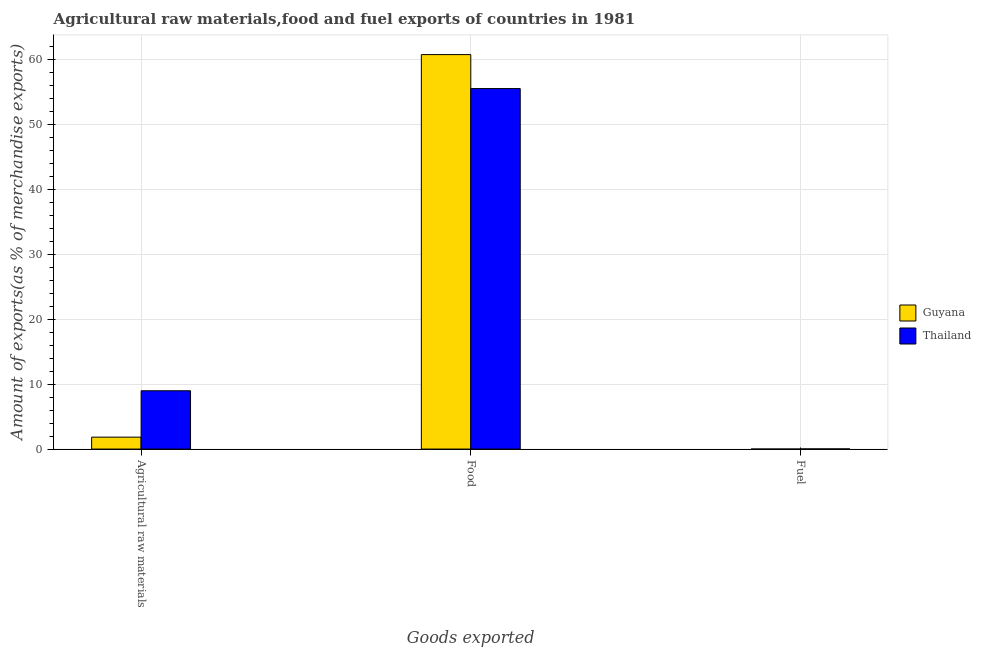How many different coloured bars are there?
Offer a terse response. 2. How many groups of bars are there?
Provide a short and direct response. 3. Are the number of bars on each tick of the X-axis equal?
Offer a very short reply. Yes. How many bars are there on the 1st tick from the right?
Your response must be concise. 2. What is the label of the 2nd group of bars from the left?
Offer a terse response. Food. What is the percentage of fuel exports in Thailand?
Offer a very short reply. 0.02. Across all countries, what is the maximum percentage of food exports?
Your response must be concise. 60.74. Across all countries, what is the minimum percentage of food exports?
Your answer should be very brief. 55.51. In which country was the percentage of fuel exports maximum?
Your answer should be very brief. Thailand. In which country was the percentage of fuel exports minimum?
Your response must be concise. Guyana. What is the total percentage of raw materials exports in the graph?
Keep it short and to the point. 10.82. What is the difference between the percentage of food exports in Thailand and that in Guyana?
Keep it short and to the point. -5.23. What is the difference between the percentage of fuel exports in Guyana and the percentage of raw materials exports in Thailand?
Keep it short and to the point. -8.98. What is the average percentage of food exports per country?
Ensure brevity in your answer.  58.13. What is the difference between the percentage of fuel exports and percentage of raw materials exports in Guyana?
Make the answer very short. -1.84. In how many countries, is the percentage of food exports greater than 26 %?
Offer a terse response. 2. What is the ratio of the percentage of fuel exports in Thailand to that in Guyana?
Offer a terse response. 395.81. Is the difference between the percentage of food exports in Guyana and Thailand greater than the difference between the percentage of raw materials exports in Guyana and Thailand?
Your answer should be compact. Yes. What is the difference between the highest and the second highest percentage of fuel exports?
Provide a short and direct response. 0.02. What is the difference between the highest and the lowest percentage of food exports?
Offer a very short reply. 5.23. In how many countries, is the percentage of food exports greater than the average percentage of food exports taken over all countries?
Make the answer very short. 1. What does the 1st bar from the left in Fuel represents?
Offer a terse response. Guyana. What does the 2nd bar from the right in Agricultural raw materials represents?
Offer a very short reply. Guyana. How many bars are there?
Your answer should be compact. 6. What is the difference between two consecutive major ticks on the Y-axis?
Provide a short and direct response. 10. Where does the legend appear in the graph?
Keep it short and to the point. Center right. How are the legend labels stacked?
Offer a very short reply. Vertical. What is the title of the graph?
Offer a terse response. Agricultural raw materials,food and fuel exports of countries in 1981. Does "New Caledonia" appear as one of the legend labels in the graph?
Provide a short and direct response. No. What is the label or title of the X-axis?
Give a very brief answer. Goods exported. What is the label or title of the Y-axis?
Give a very brief answer. Amount of exports(as % of merchandise exports). What is the Amount of exports(as % of merchandise exports) of Guyana in Agricultural raw materials?
Offer a terse response. 1.84. What is the Amount of exports(as % of merchandise exports) in Thailand in Agricultural raw materials?
Keep it short and to the point. 8.98. What is the Amount of exports(as % of merchandise exports) of Guyana in Food?
Offer a very short reply. 60.74. What is the Amount of exports(as % of merchandise exports) in Thailand in Food?
Provide a succinct answer. 55.51. What is the Amount of exports(as % of merchandise exports) in Guyana in Fuel?
Your response must be concise. 6.23484075085997e-5. What is the Amount of exports(as % of merchandise exports) in Thailand in Fuel?
Make the answer very short. 0.02. Across all Goods exported, what is the maximum Amount of exports(as % of merchandise exports) of Guyana?
Your answer should be very brief. 60.74. Across all Goods exported, what is the maximum Amount of exports(as % of merchandise exports) in Thailand?
Make the answer very short. 55.51. Across all Goods exported, what is the minimum Amount of exports(as % of merchandise exports) of Guyana?
Offer a terse response. 6.23484075085997e-5. Across all Goods exported, what is the minimum Amount of exports(as % of merchandise exports) in Thailand?
Provide a succinct answer. 0.02. What is the total Amount of exports(as % of merchandise exports) in Guyana in the graph?
Make the answer very short. 62.58. What is the total Amount of exports(as % of merchandise exports) in Thailand in the graph?
Provide a succinct answer. 64.51. What is the difference between the Amount of exports(as % of merchandise exports) in Guyana in Agricultural raw materials and that in Food?
Keep it short and to the point. -58.9. What is the difference between the Amount of exports(as % of merchandise exports) of Thailand in Agricultural raw materials and that in Food?
Your answer should be very brief. -46.53. What is the difference between the Amount of exports(as % of merchandise exports) of Guyana in Agricultural raw materials and that in Fuel?
Provide a short and direct response. 1.84. What is the difference between the Amount of exports(as % of merchandise exports) in Thailand in Agricultural raw materials and that in Fuel?
Give a very brief answer. 8.96. What is the difference between the Amount of exports(as % of merchandise exports) in Guyana in Food and that in Fuel?
Give a very brief answer. 60.74. What is the difference between the Amount of exports(as % of merchandise exports) of Thailand in Food and that in Fuel?
Offer a terse response. 55.48. What is the difference between the Amount of exports(as % of merchandise exports) in Guyana in Agricultural raw materials and the Amount of exports(as % of merchandise exports) in Thailand in Food?
Give a very brief answer. -53.67. What is the difference between the Amount of exports(as % of merchandise exports) of Guyana in Agricultural raw materials and the Amount of exports(as % of merchandise exports) of Thailand in Fuel?
Make the answer very short. 1.81. What is the difference between the Amount of exports(as % of merchandise exports) of Guyana in Food and the Amount of exports(as % of merchandise exports) of Thailand in Fuel?
Offer a terse response. 60.72. What is the average Amount of exports(as % of merchandise exports) in Guyana per Goods exported?
Keep it short and to the point. 20.86. What is the average Amount of exports(as % of merchandise exports) of Thailand per Goods exported?
Offer a terse response. 21.5. What is the difference between the Amount of exports(as % of merchandise exports) of Guyana and Amount of exports(as % of merchandise exports) of Thailand in Agricultural raw materials?
Your answer should be very brief. -7.14. What is the difference between the Amount of exports(as % of merchandise exports) in Guyana and Amount of exports(as % of merchandise exports) in Thailand in Food?
Offer a terse response. 5.23. What is the difference between the Amount of exports(as % of merchandise exports) of Guyana and Amount of exports(as % of merchandise exports) of Thailand in Fuel?
Give a very brief answer. -0.02. What is the ratio of the Amount of exports(as % of merchandise exports) in Guyana in Agricultural raw materials to that in Food?
Your answer should be compact. 0.03. What is the ratio of the Amount of exports(as % of merchandise exports) in Thailand in Agricultural raw materials to that in Food?
Provide a succinct answer. 0.16. What is the ratio of the Amount of exports(as % of merchandise exports) in Guyana in Agricultural raw materials to that in Fuel?
Offer a terse response. 2.95e+04. What is the ratio of the Amount of exports(as % of merchandise exports) of Thailand in Agricultural raw materials to that in Fuel?
Your answer should be compact. 363.89. What is the ratio of the Amount of exports(as % of merchandise exports) of Guyana in Food to that in Fuel?
Ensure brevity in your answer.  9.74e+05. What is the ratio of the Amount of exports(as % of merchandise exports) of Thailand in Food to that in Fuel?
Provide a short and direct response. 2249.34. What is the difference between the highest and the second highest Amount of exports(as % of merchandise exports) in Guyana?
Provide a short and direct response. 58.9. What is the difference between the highest and the second highest Amount of exports(as % of merchandise exports) of Thailand?
Provide a succinct answer. 46.53. What is the difference between the highest and the lowest Amount of exports(as % of merchandise exports) in Guyana?
Provide a short and direct response. 60.74. What is the difference between the highest and the lowest Amount of exports(as % of merchandise exports) in Thailand?
Make the answer very short. 55.48. 